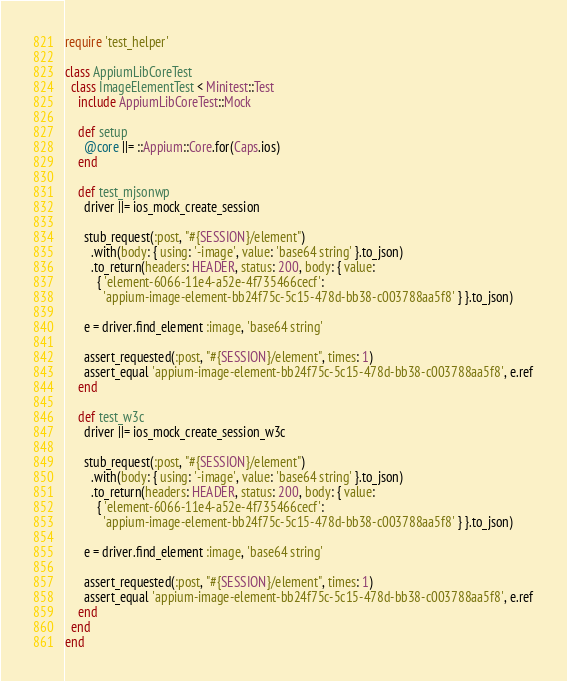<code> <loc_0><loc_0><loc_500><loc_500><_Ruby_>require 'test_helper'

class AppiumLibCoreTest
  class ImageElementTest < Minitest::Test
    include AppiumLibCoreTest::Mock

    def setup
      @core ||= ::Appium::Core.for(Caps.ios)
    end

    def test_mjsonwp
      driver ||= ios_mock_create_session

      stub_request(:post, "#{SESSION}/element")
        .with(body: { using: '-image', value: 'base64 string' }.to_json)
        .to_return(headers: HEADER, status: 200, body: { value:
          { 'element-6066-11e4-a52e-4f735466cecf':
            'appium-image-element-bb24f75c-5c15-478d-bb38-c003788aa5f8' } }.to_json)

      e = driver.find_element :image, 'base64 string'

      assert_requested(:post, "#{SESSION}/element", times: 1)
      assert_equal 'appium-image-element-bb24f75c-5c15-478d-bb38-c003788aa5f8', e.ref
    end

    def test_w3c
      driver ||= ios_mock_create_session_w3c

      stub_request(:post, "#{SESSION}/element")
        .with(body: { using: '-image', value: 'base64 string' }.to_json)
        .to_return(headers: HEADER, status: 200, body: { value:
          { 'element-6066-11e4-a52e-4f735466cecf':
            'appium-image-element-bb24f75c-5c15-478d-bb38-c003788aa5f8' } }.to_json)

      e = driver.find_element :image, 'base64 string'

      assert_requested(:post, "#{SESSION}/element", times: 1)
      assert_equal 'appium-image-element-bb24f75c-5c15-478d-bb38-c003788aa5f8', e.ref
    end
  end
end
</code> 